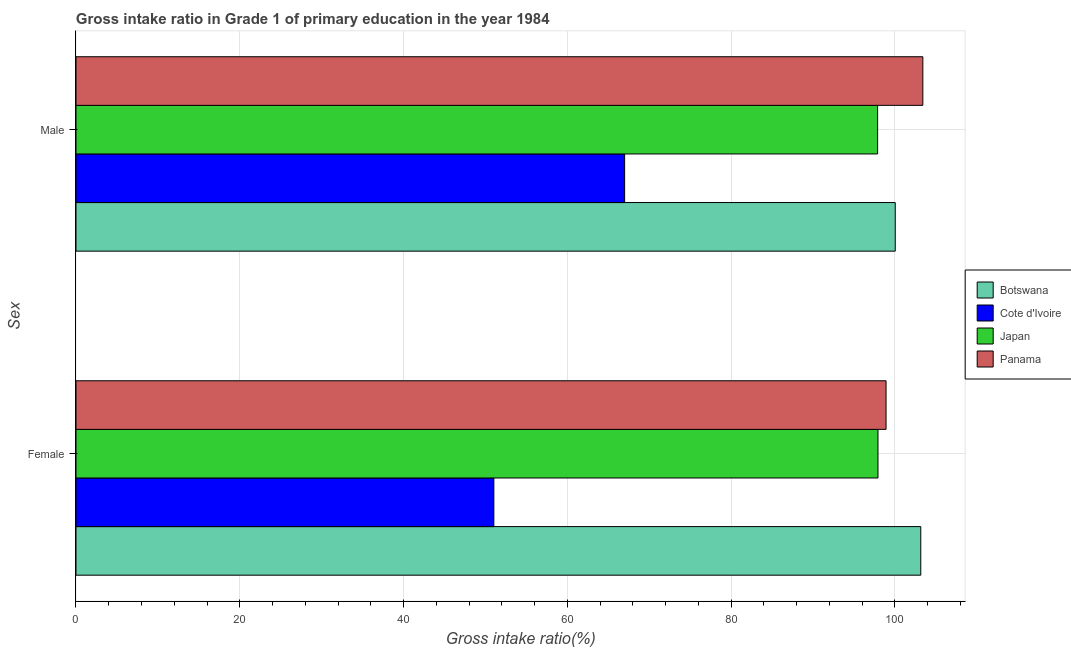How many different coloured bars are there?
Your answer should be very brief. 4. Are the number of bars per tick equal to the number of legend labels?
Your response must be concise. Yes. How many bars are there on the 1st tick from the top?
Give a very brief answer. 4. How many bars are there on the 1st tick from the bottom?
Offer a very short reply. 4. What is the gross intake ratio(male) in Cote d'Ivoire?
Your response must be concise. 67. Across all countries, what is the maximum gross intake ratio(male)?
Make the answer very short. 103.43. Across all countries, what is the minimum gross intake ratio(female)?
Keep it short and to the point. 51.03. In which country was the gross intake ratio(male) maximum?
Your response must be concise. Panama. In which country was the gross intake ratio(female) minimum?
Offer a very short reply. Cote d'Ivoire. What is the total gross intake ratio(female) in the graph?
Provide a short and direct response. 351.09. What is the difference between the gross intake ratio(male) in Japan and that in Panama?
Make the answer very short. -5.52. What is the difference between the gross intake ratio(male) in Panama and the gross intake ratio(female) in Japan?
Provide a succinct answer. 5.48. What is the average gross intake ratio(female) per country?
Provide a succinct answer. 87.77. What is the difference between the gross intake ratio(female) and gross intake ratio(male) in Panama?
Provide a succinct answer. -4.49. In how many countries, is the gross intake ratio(male) greater than 52 %?
Ensure brevity in your answer.  4. What is the ratio of the gross intake ratio(female) in Japan to that in Cote d'Ivoire?
Offer a terse response. 1.92. Is the gross intake ratio(female) in Cote d'Ivoire less than that in Panama?
Offer a very short reply. Yes. What does the 2nd bar from the bottom in Male represents?
Provide a succinct answer. Cote d'Ivoire. Are all the bars in the graph horizontal?
Ensure brevity in your answer.  Yes. What is the difference between two consecutive major ticks on the X-axis?
Offer a very short reply. 20. Does the graph contain grids?
Your answer should be compact. Yes. How many legend labels are there?
Your answer should be compact. 4. How are the legend labels stacked?
Offer a terse response. Vertical. What is the title of the graph?
Provide a short and direct response. Gross intake ratio in Grade 1 of primary education in the year 1984. What is the label or title of the X-axis?
Make the answer very short. Gross intake ratio(%). What is the label or title of the Y-axis?
Offer a very short reply. Sex. What is the Gross intake ratio(%) of Botswana in Female?
Provide a short and direct response. 103.18. What is the Gross intake ratio(%) in Cote d'Ivoire in Female?
Your answer should be compact. 51.03. What is the Gross intake ratio(%) in Japan in Female?
Your answer should be compact. 97.95. What is the Gross intake ratio(%) of Panama in Female?
Offer a very short reply. 98.93. What is the Gross intake ratio(%) in Botswana in Male?
Make the answer very short. 100.06. What is the Gross intake ratio(%) of Cote d'Ivoire in Male?
Your response must be concise. 67. What is the Gross intake ratio(%) of Japan in Male?
Your response must be concise. 97.9. What is the Gross intake ratio(%) of Panama in Male?
Offer a very short reply. 103.43. Across all Sex, what is the maximum Gross intake ratio(%) of Botswana?
Your answer should be very brief. 103.18. Across all Sex, what is the maximum Gross intake ratio(%) in Cote d'Ivoire?
Offer a terse response. 67. Across all Sex, what is the maximum Gross intake ratio(%) in Japan?
Offer a terse response. 97.95. Across all Sex, what is the maximum Gross intake ratio(%) of Panama?
Provide a succinct answer. 103.43. Across all Sex, what is the minimum Gross intake ratio(%) of Botswana?
Provide a succinct answer. 100.06. Across all Sex, what is the minimum Gross intake ratio(%) in Cote d'Ivoire?
Provide a short and direct response. 51.03. Across all Sex, what is the minimum Gross intake ratio(%) in Japan?
Provide a succinct answer. 97.9. Across all Sex, what is the minimum Gross intake ratio(%) of Panama?
Give a very brief answer. 98.93. What is the total Gross intake ratio(%) in Botswana in the graph?
Your answer should be very brief. 203.23. What is the total Gross intake ratio(%) in Cote d'Ivoire in the graph?
Your response must be concise. 118.04. What is the total Gross intake ratio(%) of Japan in the graph?
Offer a very short reply. 195.85. What is the total Gross intake ratio(%) in Panama in the graph?
Provide a short and direct response. 202.36. What is the difference between the Gross intake ratio(%) in Botswana in Female and that in Male?
Keep it short and to the point. 3.12. What is the difference between the Gross intake ratio(%) of Cote d'Ivoire in Female and that in Male?
Make the answer very short. -15.97. What is the difference between the Gross intake ratio(%) in Japan in Female and that in Male?
Keep it short and to the point. 0.05. What is the difference between the Gross intake ratio(%) of Panama in Female and that in Male?
Make the answer very short. -4.49. What is the difference between the Gross intake ratio(%) in Botswana in Female and the Gross intake ratio(%) in Cote d'Ivoire in Male?
Make the answer very short. 36.17. What is the difference between the Gross intake ratio(%) in Botswana in Female and the Gross intake ratio(%) in Japan in Male?
Your response must be concise. 5.27. What is the difference between the Gross intake ratio(%) in Botswana in Female and the Gross intake ratio(%) in Panama in Male?
Keep it short and to the point. -0.25. What is the difference between the Gross intake ratio(%) in Cote d'Ivoire in Female and the Gross intake ratio(%) in Japan in Male?
Ensure brevity in your answer.  -46.87. What is the difference between the Gross intake ratio(%) of Cote d'Ivoire in Female and the Gross intake ratio(%) of Panama in Male?
Your answer should be compact. -52.39. What is the difference between the Gross intake ratio(%) of Japan in Female and the Gross intake ratio(%) of Panama in Male?
Give a very brief answer. -5.48. What is the average Gross intake ratio(%) of Botswana per Sex?
Your answer should be very brief. 101.62. What is the average Gross intake ratio(%) in Cote d'Ivoire per Sex?
Ensure brevity in your answer.  59.02. What is the average Gross intake ratio(%) of Japan per Sex?
Provide a succinct answer. 97.93. What is the average Gross intake ratio(%) in Panama per Sex?
Keep it short and to the point. 101.18. What is the difference between the Gross intake ratio(%) in Botswana and Gross intake ratio(%) in Cote d'Ivoire in Female?
Make the answer very short. 52.14. What is the difference between the Gross intake ratio(%) of Botswana and Gross intake ratio(%) of Japan in Female?
Make the answer very short. 5.23. What is the difference between the Gross intake ratio(%) in Botswana and Gross intake ratio(%) in Panama in Female?
Offer a terse response. 4.24. What is the difference between the Gross intake ratio(%) of Cote d'Ivoire and Gross intake ratio(%) of Japan in Female?
Offer a terse response. -46.91. What is the difference between the Gross intake ratio(%) in Cote d'Ivoire and Gross intake ratio(%) in Panama in Female?
Your response must be concise. -47.9. What is the difference between the Gross intake ratio(%) of Japan and Gross intake ratio(%) of Panama in Female?
Your answer should be very brief. -0.99. What is the difference between the Gross intake ratio(%) of Botswana and Gross intake ratio(%) of Cote d'Ivoire in Male?
Offer a very short reply. 33.05. What is the difference between the Gross intake ratio(%) of Botswana and Gross intake ratio(%) of Japan in Male?
Your response must be concise. 2.15. What is the difference between the Gross intake ratio(%) in Botswana and Gross intake ratio(%) in Panama in Male?
Give a very brief answer. -3.37. What is the difference between the Gross intake ratio(%) in Cote d'Ivoire and Gross intake ratio(%) in Japan in Male?
Offer a terse response. -30.9. What is the difference between the Gross intake ratio(%) of Cote d'Ivoire and Gross intake ratio(%) of Panama in Male?
Provide a succinct answer. -36.42. What is the difference between the Gross intake ratio(%) of Japan and Gross intake ratio(%) of Panama in Male?
Make the answer very short. -5.52. What is the ratio of the Gross intake ratio(%) of Botswana in Female to that in Male?
Ensure brevity in your answer.  1.03. What is the ratio of the Gross intake ratio(%) of Cote d'Ivoire in Female to that in Male?
Your answer should be very brief. 0.76. What is the ratio of the Gross intake ratio(%) of Panama in Female to that in Male?
Your answer should be compact. 0.96. What is the difference between the highest and the second highest Gross intake ratio(%) in Botswana?
Make the answer very short. 3.12. What is the difference between the highest and the second highest Gross intake ratio(%) in Cote d'Ivoire?
Your answer should be very brief. 15.97. What is the difference between the highest and the second highest Gross intake ratio(%) in Japan?
Provide a succinct answer. 0.05. What is the difference between the highest and the second highest Gross intake ratio(%) of Panama?
Give a very brief answer. 4.49. What is the difference between the highest and the lowest Gross intake ratio(%) in Botswana?
Provide a succinct answer. 3.12. What is the difference between the highest and the lowest Gross intake ratio(%) of Cote d'Ivoire?
Ensure brevity in your answer.  15.97. What is the difference between the highest and the lowest Gross intake ratio(%) of Japan?
Make the answer very short. 0.05. What is the difference between the highest and the lowest Gross intake ratio(%) in Panama?
Your response must be concise. 4.49. 